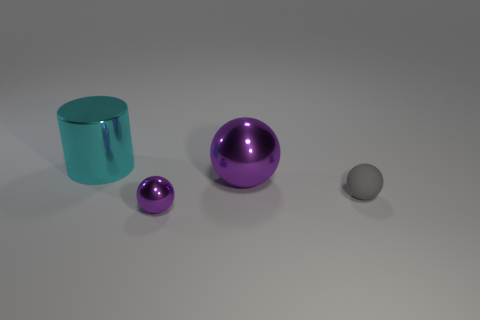Subtract all blue balls. Subtract all gray blocks. How many balls are left? 3 Add 2 small green matte cylinders. How many objects exist? 6 Subtract all spheres. How many objects are left? 1 Add 1 tiny purple metallic balls. How many tiny purple metallic balls are left? 2 Add 1 red rubber cylinders. How many red rubber cylinders exist? 1 Subtract 0 blue spheres. How many objects are left? 4 Subtract all tiny shiny balls. Subtract all small red balls. How many objects are left? 3 